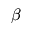<formula> <loc_0><loc_0><loc_500><loc_500>\beta</formula> 